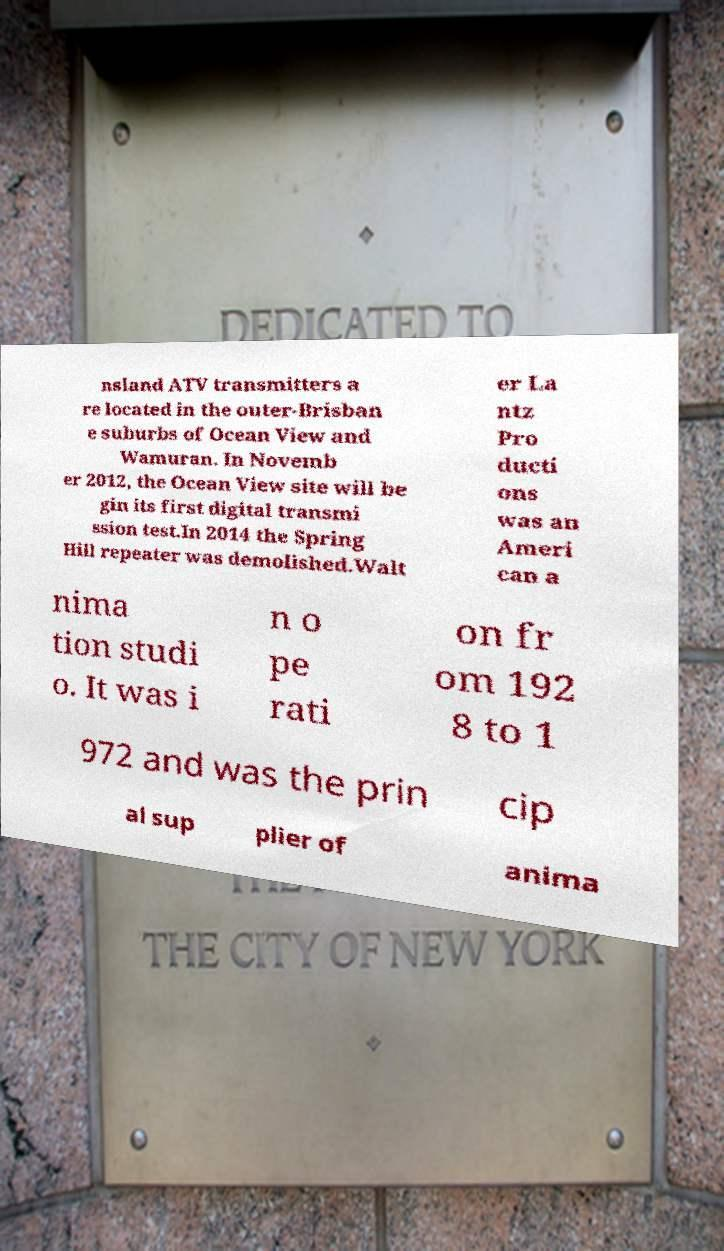Could you extract and type out the text from this image? nsland ATV transmitters a re located in the outer-Brisban e suburbs of Ocean View and Wamuran. In Novemb er 2012, the Ocean View site will be gin its first digital transmi ssion test.In 2014 the Spring Hill repeater was demolished.Walt er La ntz Pro ducti ons was an Ameri can a nima tion studi o. It was i n o pe rati on fr om 192 8 to 1 972 and was the prin cip al sup plier of anima 